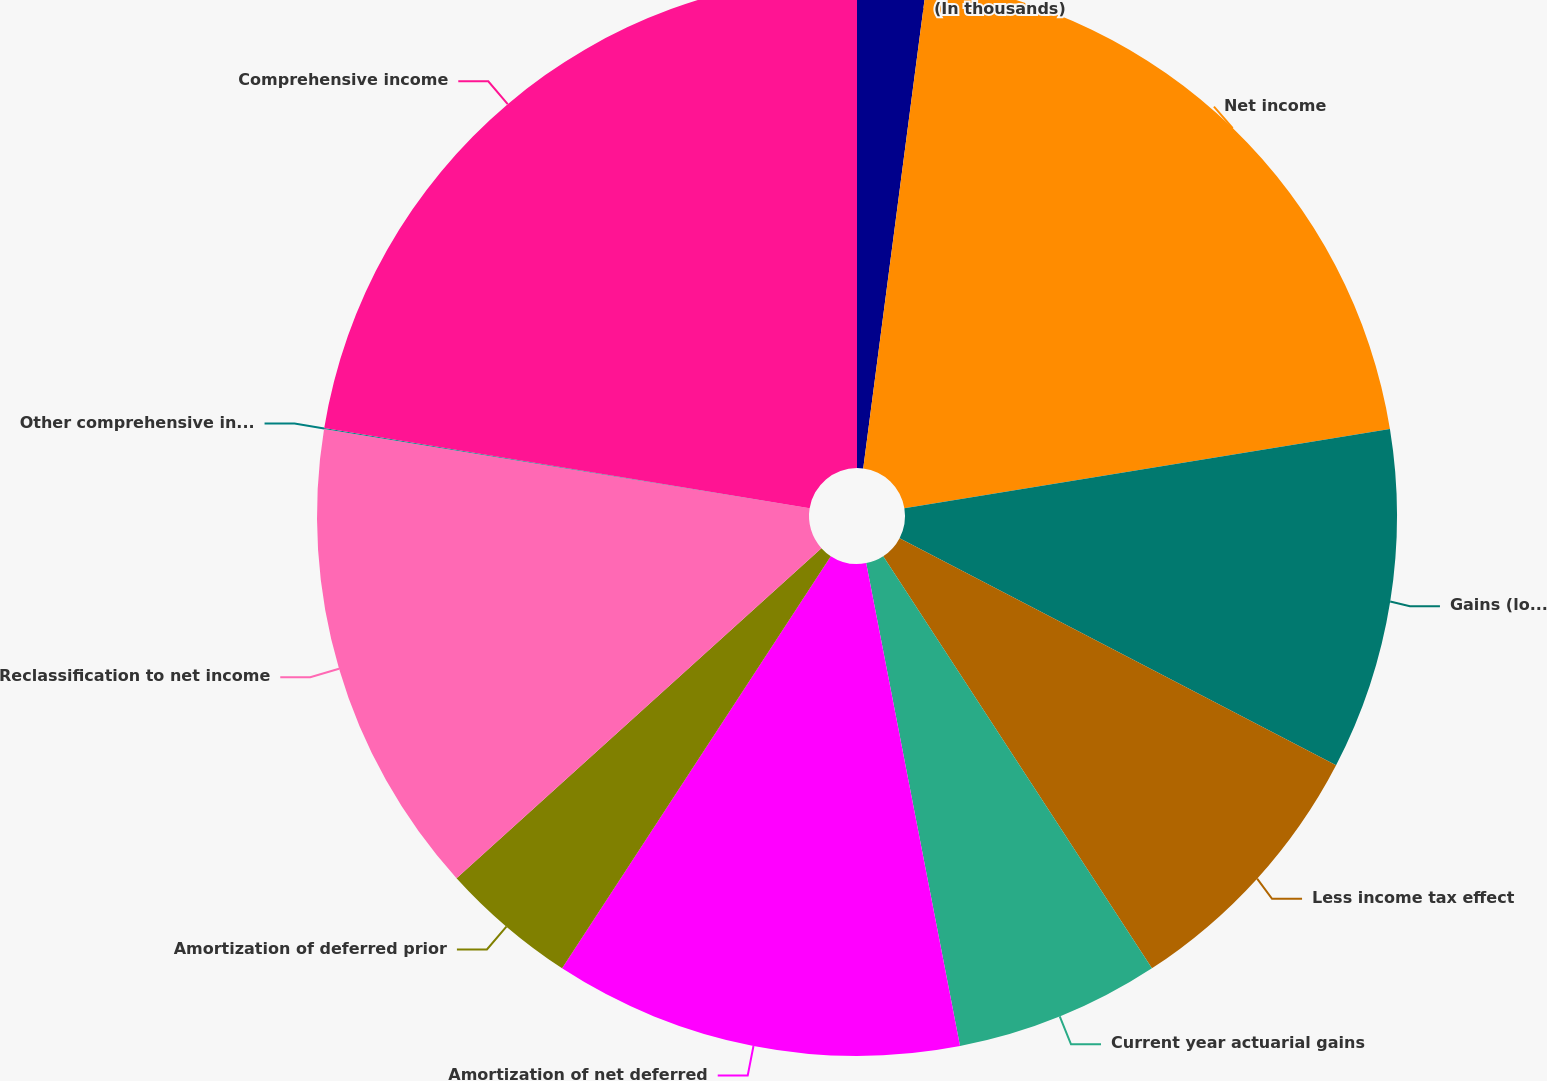Convert chart to OTSL. <chart><loc_0><loc_0><loc_500><loc_500><pie_chart><fcel>(In thousands)<fcel>Net income<fcel>Gains (losses) arising during<fcel>Less income tax effect<fcel>Current year actuarial gains<fcel>Amortization of net deferred<fcel>Amortization of deferred prior<fcel>Reclassification to net income<fcel>Other comprehensive income<fcel>Comprehensive income<nl><fcel>2.07%<fcel>20.35%<fcel>10.21%<fcel>8.17%<fcel>6.14%<fcel>12.25%<fcel>4.1%<fcel>14.28%<fcel>0.03%<fcel>22.39%<nl></chart> 